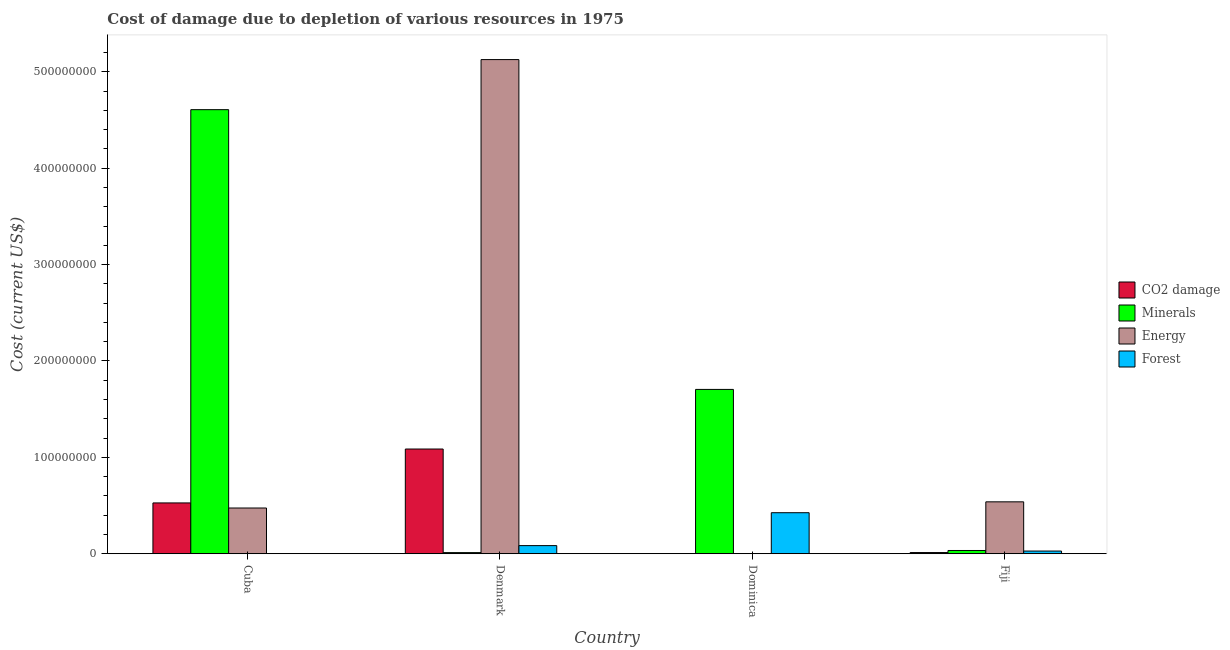How many different coloured bars are there?
Your response must be concise. 4. How many groups of bars are there?
Your response must be concise. 4. How many bars are there on the 2nd tick from the right?
Provide a short and direct response. 4. What is the label of the 1st group of bars from the left?
Your response must be concise. Cuba. In how many cases, is the number of bars for a given country not equal to the number of legend labels?
Your response must be concise. 0. What is the cost of damage due to depletion of minerals in Fiji?
Make the answer very short. 3.35e+06. Across all countries, what is the maximum cost of damage due to depletion of minerals?
Keep it short and to the point. 4.61e+08. Across all countries, what is the minimum cost of damage due to depletion of forests?
Give a very brief answer. 1.50e+05. What is the total cost of damage due to depletion of coal in the graph?
Your response must be concise. 1.63e+08. What is the difference between the cost of damage due to depletion of minerals in Cuba and that in Fiji?
Provide a succinct answer. 4.57e+08. What is the difference between the cost of damage due to depletion of forests in Cuba and the cost of damage due to depletion of energy in Dominica?
Your answer should be very brief. 5.20e+04. What is the average cost of damage due to depletion of coal per country?
Ensure brevity in your answer.  4.07e+07. What is the difference between the cost of damage due to depletion of forests and cost of damage due to depletion of minerals in Denmark?
Offer a terse response. 7.26e+06. What is the ratio of the cost of damage due to depletion of coal in Cuba to that in Denmark?
Your answer should be compact. 0.49. Is the cost of damage due to depletion of coal in Cuba less than that in Dominica?
Provide a short and direct response. No. Is the difference between the cost of damage due to depletion of coal in Cuba and Denmark greater than the difference between the cost of damage due to depletion of minerals in Cuba and Denmark?
Provide a short and direct response. No. What is the difference between the highest and the second highest cost of damage due to depletion of minerals?
Your answer should be compact. 2.90e+08. What is the difference between the highest and the lowest cost of damage due to depletion of minerals?
Your answer should be very brief. 4.60e+08. In how many countries, is the cost of damage due to depletion of energy greater than the average cost of damage due to depletion of energy taken over all countries?
Give a very brief answer. 1. Is the sum of the cost of damage due to depletion of coal in Cuba and Dominica greater than the maximum cost of damage due to depletion of minerals across all countries?
Your response must be concise. No. What does the 1st bar from the left in Fiji represents?
Provide a succinct answer. CO2 damage. What does the 3rd bar from the right in Fiji represents?
Your response must be concise. Minerals. Is it the case that in every country, the sum of the cost of damage due to depletion of coal and cost of damage due to depletion of minerals is greater than the cost of damage due to depletion of energy?
Your response must be concise. No. How many bars are there?
Make the answer very short. 16. Are all the bars in the graph horizontal?
Your answer should be compact. No. How many countries are there in the graph?
Offer a terse response. 4. What is the difference between two consecutive major ticks on the Y-axis?
Your answer should be compact. 1.00e+08. Does the graph contain grids?
Offer a very short reply. No. Where does the legend appear in the graph?
Provide a short and direct response. Center right. How many legend labels are there?
Give a very brief answer. 4. How are the legend labels stacked?
Make the answer very short. Vertical. What is the title of the graph?
Give a very brief answer. Cost of damage due to depletion of various resources in 1975 . Does "Quality Certification" appear as one of the legend labels in the graph?
Offer a terse response. No. What is the label or title of the X-axis?
Offer a terse response. Country. What is the label or title of the Y-axis?
Keep it short and to the point. Cost (current US$). What is the Cost (current US$) in CO2 damage in Cuba?
Ensure brevity in your answer.  5.27e+07. What is the Cost (current US$) of Minerals in Cuba?
Provide a succinct answer. 4.61e+08. What is the Cost (current US$) in Energy in Cuba?
Your response must be concise. 4.74e+07. What is the Cost (current US$) in Forest in Cuba?
Ensure brevity in your answer.  1.50e+05. What is the Cost (current US$) of CO2 damage in Denmark?
Give a very brief answer. 1.09e+08. What is the Cost (current US$) of Minerals in Denmark?
Provide a short and direct response. 1.16e+06. What is the Cost (current US$) of Energy in Denmark?
Your answer should be compact. 5.13e+08. What is the Cost (current US$) in Forest in Denmark?
Make the answer very short. 8.42e+06. What is the Cost (current US$) in CO2 damage in Dominica?
Your response must be concise. 5.71e+04. What is the Cost (current US$) of Minerals in Dominica?
Your answer should be very brief. 1.70e+08. What is the Cost (current US$) of Energy in Dominica?
Provide a succinct answer. 9.80e+04. What is the Cost (current US$) of Forest in Dominica?
Ensure brevity in your answer.  4.26e+07. What is the Cost (current US$) of CO2 damage in Fiji?
Give a very brief answer. 1.21e+06. What is the Cost (current US$) of Minerals in Fiji?
Ensure brevity in your answer.  3.35e+06. What is the Cost (current US$) in Energy in Fiji?
Offer a terse response. 5.39e+07. What is the Cost (current US$) in Forest in Fiji?
Your answer should be very brief. 2.78e+06. Across all countries, what is the maximum Cost (current US$) in CO2 damage?
Provide a short and direct response. 1.09e+08. Across all countries, what is the maximum Cost (current US$) of Minerals?
Give a very brief answer. 4.61e+08. Across all countries, what is the maximum Cost (current US$) of Energy?
Provide a short and direct response. 5.13e+08. Across all countries, what is the maximum Cost (current US$) in Forest?
Your answer should be compact. 4.26e+07. Across all countries, what is the minimum Cost (current US$) in CO2 damage?
Offer a very short reply. 5.71e+04. Across all countries, what is the minimum Cost (current US$) in Minerals?
Your answer should be compact. 1.16e+06. Across all countries, what is the minimum Cost (current US$) of Energy?
Provide a short and direct response. 9.80e+04. Across all countries, what is the minimum Cost (current US$) of Forest?
Offer a very short reply. 1.50e+05. What is the total Cost (current US$) in CO2 damage in the graph?
Make the answer very short. 1.63e+08. What is the total Cost (current US$) of Minerals in the graph?
Give a very brief answer. 6.36e+08. What is the total Cost (current US$) in Energy in the graph?
Your response must be concise. 6.14e+08. What is the total Cost (current US$) in Forest in the graph?
Your response must be concise. 5.39e+07. What is the difference between the Cost (current US$) of CO2 damage in Cuba and that in Denmark?
Your answer should be compact. -5.59e+07. What is the difference between the Cost (current US$) in Minerals in Cuba and that in Denmark?
Make the answer very short. 4.60e+08. What is the difference between the Cost (current US$) of Energy in Cuba and that in Denmark?
Provide a succinct answer. -4.65e+08. What is the difference between the Cost (current US$) of Forest in Cuba and that in Denmark?
Keep it short and to the point. -8.27e+06. What is the difference between the Cost (current US$) in CO2 damage in Cuba and that in Dominica?
Provide a succinct answer. 5.27e+07. What is the difference between the Cost (current US$) in Minerals in Cuba and that in Dominica?
Give a very brief answer. 2.90e+08. What is the difference between the Cost (current US$) in Energy in Cuba and that in Dominica?
Your response must be concise. 4.73e+07. What is the difference between the Cost (current US$) in Forest in Cuba and that in Dominica?
Make the answer very short. -4.24e+07. What is the difference between the Cost (current US$) in CO2 damage in Cuba and that in Fiji?
Make the answer very short. 5.15e+07. What is the difference between the Cost (current US$) of Minerals in Cuba and that in Fiji?
Offer a very short reply. 4.57e+08. What is the difference between the Cost (current US$) in Energy in Cuba and that in Fiji?
Your answer should be compact. -6.41e+06. What is the difference between the Cost (current US$) of Forest in Cuba and that in Fiji?
Give a very brief answer. -2.63e+06. What is the difference between the Cost (current US$) in CO2 damage in Denmark and that in Dominica?
Keep it short and to the point. 1.09e+08. What is the difference between the Cost (current US$) of Minerals in Denmark and that in Dominica?
Make the answer very short. -1.69e+08. What is the difference between the Cost (current US$) of Energy in Denmark and that in Dominica?
Give a very brief answer. 5.13e+08. What is the difference between the Cost (current US$) in Forest in Denmark and that in Dominica?
Make the answer very short. -3.42e+07. What is the difference between the Cost (current US$) in CO2 damage in Denmark and that in Fiji?
Provide a short and direct response. 1.07e+08. What is the difference between the Cost (current US$) of Minerals in Denmark and that in Fiji?
Offer a terse response. -2.20e+06. What is the difference between the Cost (current US$) in Energy in Denmark and that in Fiji?
Your answer should be compact. 4.59e+08. What is the difference between the Cost (current US$) in Forest in Denmark and that in Fiji?
Offer a terse response. 5.63e+06. What is the difference between the Cost (current US$) of CO2 damage in Dominica and that in Fiji?
Provide a succinct answer. -1.16e+06. What is the difference between the Cost (current US$) of Minerals in Dominica and that in Fiji?
Offer a terse response. 1.67e+08. What is the difference between the Cost (current US$) of Energy in Dominica and that in Fiji?
Keep it short and to the point. -5.38e+07. What is the difference between the Cost (current US$) of Forest in Dominica and that in Fiji?
Keep it short and to the point. 3.98e+07. What is the difference between the Cost (current US$) of CO2 damage in Cuba and the Cost (current US$) of Minerals in Denmark?
Ensure brevity in your answer.  5.16e+07. What is the difference between the Cost (current US$) of CO2 damage in Cuba and the Cost (current US$) of Energy in Denmark?
Make the answer very short. -4.60e+08. What is the difference between the Cost (current US$) in CO2 damage in Cuba and the Cost (current US$) in Forest in Denmark?
Keep it short and to the point. 4.43e+07. What is the difference between the Cost (current US$) of Minerals in Cuba and the Cost (current US$) of Energy in Denmark?
Make the answer very short. -5.20e+07. What is the difference between the Cost (current US$) of Minerals in Cuba and the Cost (current US$) of Forest in Denmark?
Your answer should be very brief. 4.52e+08. What is the difference between the Cost (current US$) in Energy in Cuba and the Cost (current US$) in Forest in Denmark?
Provide a succinct answer. 3.90e+07. What is the difference between the Cost (current US$) in CO2 damage in Cuba and the Cost (current US$) in Minerals in Dominica?
Make the answer very short. -1.18e+08. What is the difference between the Cost (current US$) in CO2 damage in Cuba and the Cost (current US$) in Energy in Dominica?
Offer a very short reply. 5.26e+07. What is the difference between the Cost (current US$) in CO2 damage in Cuba and the Cost (current US$) in Forest in Dominica?
Ensure brevity in your answer.  1.01e+07. What is the difference between the Cost (current US$) of Minerals in Cuba and the Cost (current US$) of Energy in Dominica?
Give a very brief answer. 4.61e+08. What is the difference between the Cost (current US$) of Minerals in Cuba and the Cost (current US$) of Forest in Dominica?
Your answer should be compact. 4.18e+08. What is the difference between the Cost (current US$) in Energy in Cuba and the Cost (current US$) in Forest in Dominica?
Your answer should be very brief. 4.87e+06. What is the difference between the Cost (current US$) in CO2 damage in Cuba and the Cost (current US$) in Minerals in Fiji?
Offer a very short reply. 4.94e+07. What is the difference between the Cost (current US$) of CO2 damage in Cuba and the Cost (current US$) of Energy in Fiji?
Provide a short and direct response. -1.14e+06. What is the difference between the Cost (current US$) of CO2 damage in Cuba and the Cost (current US$) of Forest in Fiji?
Offer a terse response. 4.99e+07. What is the difference between the Cost (current US$) of Minerals in Cuba and the Cost (current US$) of Energy in Fiji?
Provide a succinct answer. 4.07e+08. What is the difference between the Cost (current US$) in Minerals in Cuba and the Cost (current US$) in Forest in Fiji?
Your answer should be very brief. 4.58e+08. What is the difference between the Cost (current US$) of Energy in Cuba and the Cost (current US$) of Forest in Fiji?
Offer a very short reply. 4.47e+07. What is the difference between the Cost (current US$) of CO2 damage in Denmark and the Cost (current US$) of Minerals in Dominica?
Ensure brevity in your answer.  -6.18e+07. What is the difference between the Cost (current US$) in CO2 damage in Denmark and the Cost (current US$) in Energy in Dominica?
Make the answer very short. 1.09e+08. What is the difference between the Cost (current US$) in CO2 damage in Denmark and the Cost (current US$) in Forest in Dominica?
Give a very brief answer. 6.61e+07. What is the difference between the Cost (current US$) in Minerals in Denmark and the Cost (current US$) in Energy in Dominica?
Ensure brevity in your answer.  1.06e+06. What is the difference between the Cost (current US$) in Minerals in Denmark and the Cost (current US$) in Forest in Dominica?
Your answer should be compact. -4.14e+07. What is the difference between the Cost (current US$) in Energy in Denmark and the Cost (current US$) in Forest in Dominica?
Offer a terse response. 4.70e+08. What is the difference between the Cost (current US$) in CO2 damage in Denmark and the Cost (current US$) in Minerals in Fiji?
Give a very brief answer. 1.05e+08. What is the difference between the Cost (current US$) in CO2 damage in Denmark and the Cost (current US$) in Energy in Fiji?
Ensure brevity in your answer.  5.48e+07. What is the difference between the Cost (current US$) of CO2 damage in Denmark and the Cost (current US$) of Forest in Fiji?
Your answer should be very brief. 1.06e+08. What is the difference between the Cost (current US$) in Minerals in Denmark and the Cost (current US$) in Energy in Fiji?
Provide a succinct answer. -5.27e+07. What is the difference between the Cost (current US$) of Minerals in Denmark and the Cost (current US$) of Forest in Fiji?
Offer a very short reply. -1.62e+06. What is the difference between the Cost (current US$) of Energy in Denmark and the Cost (current US$) of Forest in Fiji?
Your response must be concise. 5.10e+08. What is the difference between the Cost (current US$) in CO2 damage in Dominica and the Cost (current US$) in Minerals in Fiji?
Offer a terse response. -3.30e+06. What is the difference between the Cost (current US$) in CO2 damage in Dominica and the Cost (current US$) in Energy in Fiji?
Make the answer very short. -5.38e+07. What is the difference between the Cost (current US$) of CO2 damage in Dominica and the Cost (current US$) of Forest in Fiji?
Your answer should be very brief. -2.72e+06. What is the difference between the Cost (current US$) in Minerals in Dominica and the Cost (current US$) in Energy in Fiji?
Ensure brevity in your answer.  1.17e+08. What is the difference between the Cost (current US$) of Minerals in Dominica and the Cost (current US$) of Forest in Fiji?
Provide a succinct answer. 1.68e+08. What is the difference between the Cost (current US$) in Energy in Dominica and the Cost (current US$) in Forest in Fiji?
Keep it short and to the point. -2.68e+06. What is the average Cost (current US$) in CO2 damage per country?
Give a very brief answer. 4.07e+07. What is the average Cost (current US$) in Minerals per country?
Your answer should be very brief. 1.59e+08. What is the average Cost (current US$) in Energy per country?
Provide a succinct answer. 1.54e+08. What is the average Cost (current US$) in Forest per country?
Your response must be concise. 1.35e+07. What is the difference between the Cost (current US$) of CO2 damage and Cost (current US$) of Minerals in Cuba?
Offer a very short reply. -4.08e+08. What is the difference between the Cost (current US$) in CO2 damage and Cost (current US$) in Energy in Cuba?
Your response must be concise. 5.28e+06. What is the difference between the Cost (current US$) of CO2 damage and Cost (current US$) of Forest in Cuba?
Provide a succinct answer. 5.26e+07. What is the difference between the Cost (current US$) of Minerals and Cost (current US$) of Energy in Cuba?
Your response must be concise. 4.13e+08. What is the difference between the Cost (current US$) of Minerals and Cost (current US$) of Forest in Cuba?
Provide a short and direct response. 4.61e+08. What is the difference between the Cost (current US$) of Energy and Cost (current US$) of Forest in Cuba?
Your response must be concise. 4.73e+07. What is the difference between the Cost (current US$) in CO2 damage and Cost (current US$) in Minerals in Denmark?
Ensure brevity in your answer.  1.07e+08. What is the difference between the Cost (current US$) of CO2 damage and Cost (current US$) of Energy in Denmark?
Your answer should be compact. -4.04e+08. What is the difference between the Cost (current US$) in CO2 damage and Cost (current US$) in Forest in Denmark?
Ensure brevity in your answer.  1.00e+08. What is the difference between the Cost (current US$) in Minerals and Cost (current US$) in Energy in Denmark?
Offer a terse response. -5.12e+08. What is the difference between the Cost (current US$) in Minerals and Cost (current US$) in Forest in Denmark?
Your answer should be compact. -7.26e+06. What is the difference between the Cost (current US$) of Energy and Cost (current US$) of Forest in Denmark?
Provide a short and direct response. 5.04e+08. What is the difference between the Cost (current US$) of CO2 damage and Cost (current US$) of Minerals in Dominica?
Provide a short and direct response. -1.70e+08. What is the difference between the Cost (current US$) of CO2 damage and Cost (current US$) of Energy in Dominica?
Keep it short and to the point. -4.09e+04. What is the difference between the Cost (current US$) of CO2 damage and Cost (current US$) of Forest in Dominica?
Your answer should be very brief. -4.25e+07. What is the difference between the Cost (current US$) of Minerals and Cost (current US$) of Energy in Dominica?
Your answer should be compact. 1.70e+08. What is the difference between the Cost (current US$) of Minerals and Cost (current US$) of Forest in Dominica?
Give a very brief answer. 1.28e+08. What is the difference between the Cost (current US$) in Energy and Cost (current US$) in Forest in Dominica?
Your answer should be very brief. -4.25e+07. What is the difference between the Cost (current US$) in CO2 damage and Cost (current US$) in Minerals in Fiji?
Provide a succinct answer. -2.14e+06. What is the difference between the Cost (current US$) in CO2 damage and Cost (current US$) in Energy in Fiji?
Offer a terse response. -5.26e+07. What is the difference between the Cost (current US$) in CO2 damage and Cost (current US$) in Forest in Fiji?
Your response must be concise. -1.57e+06. What is the difference between the Cost (current US$) of Minerals and Cost (current US$) of Energy in Fiji?
Your answer should be very brief. -5.05e+07. What is the difference between the Cost (current US$) in Minerals and Cost (current US$) in Forest in Fiji?
Provide a short and direct response. 5.73e+05. What is the difference between the Cost (current US$) in Energy and Cost (current US$) in Forest in Fiji?
Keep it short and to the point. 5.11e+07. What is the ratio of the Cost (current US$) in CO2 damage in Cuba to that in Denmark?
Your response must be concise. 0.49. What is the ratio of the Cost (current US$) in Minerals in Cuba to that in Denmark?
Make the answer very short. 397.79. What is the ratio of the Cost (current US$) of Energy in Cuba to that in Denmark?
Keep it short and to the point. 0.09. What is the ratio of the Cost (current US$) in Forest in Cuba to that in Denmark?
Your answer should be compact. 0.02. What is the ratio of the Cost (current US$) in CO2 damage in Cuba to that in Dominica?
Your answer should be compact. 922.62. What is the ratio of the Cost (current US$) in Minerals in Cuba to that in Dominica?
Ensure brevity in your answer.  2.7. What is the ratio of the Cost (current US$) of Energy in Cuba to that in Dominica?
Your answer should be very brief. 483.83. What is the ratio of the Cost (current US$) of Forest in Cuba to that in Dominica?
Your response must be concise. 0. What is the ratio of the Cost (current US$) in CO2 damage in Cuba to that in Fiji?
Make the answer very short. 43.42. What is the ratio of the Cost (current US$) of Minerals in Cuba to that in Fiji?
Ensure brevity in your answer.  137.37. What is the ratio of the Cost (current US$) of Energy in Cuba to that in Fiji?
Ensure brevity in your answer.  0.88. What is the ratio of the Cost (current US$) in Forest in Cuba to that in Fiji?
Make the answer very short. 0.05. What is the ratio of the Cost (current US$) of CO2 damage in Denmark to that in Dominica?
Make the answer very short. 1901.38. What is the ratio of the Cost (current US$) in Minerals in Denmark to that in Dominica?
Offer a very short reply. 0.01. What is the ratio of the Cost (current US$) of Energy in Denmark to that in Dominica?
Give a very brief answer. 5229.38. What is the ratio of the Cost (current US$) of Forest in Denmark to that in Dominica?
Your answer should be compact. 0.2. What is the ratio of the Cost (current US$) of CO2 damage in Denmark to that in Fiji?
Provide a succinct answer. 89.48. What is the ratio of the Cost (current US$) in Minerals in Denmark to that in Fiji?
Provide a succinct answer. 0.35. What is the ratio of the Cost (current US$) in Energy in Denmark to that in Fiji?
Give a very brief answer. 9.52. What is the ratio of the Cost (current US$) in Forest in Denmark to that in Fiji?
Offer a very short reply. 3.03. What is the ratio of the Cost (current US$) of CO2 damage in Dominica to that in Fiji?
Your answer should be very brief. 0.05. What is the ratio of the Cost (current US$) of Minerals in Dominica to that in Fiji?
Keep it short and to the point. 50.83. What is the ratio of the Cost (current US$) in Energy in Dominica to that in Fiji?
Your answer should be compact. 0. What is the ratio of the Cost (current US$) of Forest in Dominica to that in Fiji?
Ensure brevity in your answer.  15.3. What is the difference between the highest and the second highest Cost (current US$) in CO2 damage?
Provide a succinct answer. 5.59e+07. What is the difference between the highest and the second highest Cost (current US$) in Minerals?
Make the answer very short. 2.90e+08. What is the difference between the highest and the second highest Cost (current US$) in Energy?
Ensure brevity in your answer.  4.59e+08. What is the difference between the highest and the second highest Cost (current US$) in Forest?
Keep it short and to the point. 3.42e+07. What is the difference between the highest and the lowest Cost (current US$) in CO2 damage?
Give a very brief answer. 1.09e+08. What is the difference between the highest and the lowest Cost (current US$) in Minerals?
Keep it short and to the point. 4.60e+08. What is the difference between the highest and the lowest Cost (current US$) in Energy?
Give a very brief answer. 5.13e+08. What is the difference between the highest and the lowest Cost (current US$) of Forest?
Provide a succinct answer. 4.24e+07. 